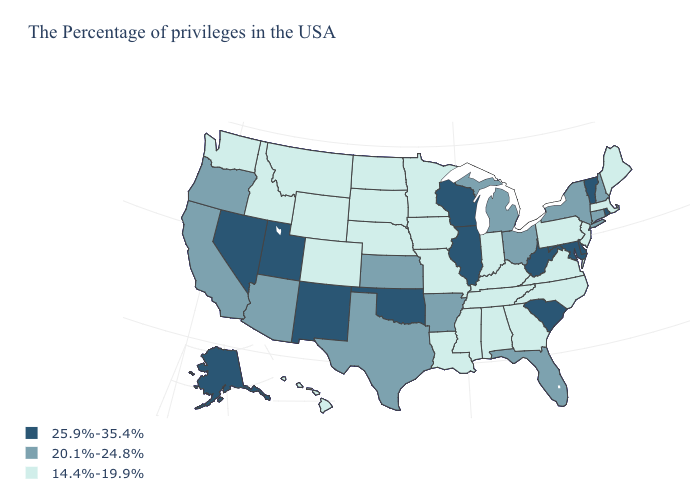Among the states that border Rhode Island , which have the highest value?
Answer briefly. Connecticut. Name the states that have a value in the range 14.4%-19.9%?
Concise answer only. Maine, Massachusetts, New Jersey, Pennsylvania, Virginia, North Carolina, Georgia, Kentucky, Indiana, Alabama, Tennessee, Mississippi, Louisiana, Missouri, Minnesota, Iowa, Nebraska, South Dakota, North Dakota, Wyoming, Colorado, Montana, Idaho, Washington, Hawaii. Does New Mexico have the highest value in the West?
Quick response, please. Yes. What is the highest value in the MidWest ?
Be succinct. 25.9%-35.4%. Name the states that have a value in the range 20.1%-24.8%?
Keep it brief. New Hampshire, Connecticut, New York, Ohio, Florida, Michigan, Arkansas, Kansas, Texas, Arizona, California, Oregon. Name the states that have a value in the range 25.9%-35.4%?
Give a very brief answer. Rhode Island, Vermont, Delaware, Maryland, South Carolina, West Virginia, Wisconsin, Illinois, Oklahoma, New Mexico, Utah, Nevada, Alaska. What is the highest value in the USA?
Quick response, please. 25.9%-35.4%. Name the states that have a value in the range 25.9%-35.4%?
Short answer required. Rhode Island, Vermont, Delaware, Maryland, South Carolina, West Virginia, Wisconsin, Illinois, Oklahoma, New Mexico, Utah, Nevada, Alaska. Which states have the lowest value in the USA?
Give a very brief answer. Maine, Massachusetts, New Jersey, Pennsylvania, Virginia, North Carolina, Georgia, Kentucky, Indiana, Alabama, Tennessee, Mississippi, Louisiana, Missouri, Minnesota, Iowa, Nebraska, South Dakota, North Dakota, Wyoming, Colorado, Montana, Idaho, Washington, Hawaii. What is the highest value in states that border Kansas?
Answer briefly. 25.9%-35.4%. Name the states that have a value in the range 14.4%-19.9%?
Be succinct. Maine, Massachusetts, New Jersey, Pennsylvania, Virginia, North Carolina, Georgia, Kentucky, Indiana, Alabama, Tennessee, Mississippi, Louisiana, Missouri, Minnesota, Iowa, Nebraska, South Dakota, North Dakota, Wyoming, Colorado, Montana, Idaho, Washington, Hawaii. Does the map have missing data?
Answer briefly. No. Which states have the lowest value in the South?
Be succinct. Virginia, North Carolina, Georgia, Kentucky, Alabama, Tennessee, Mississippi, Louisiana. Name the states that have a value in the range 14.4%-19.9%?
Quick response, please. Maine, Massachusetts, New Jersey, Pennsylvania, Virginia, North Carolina, Georgia, Kentucky, Indiana, Alabama, Tennessee, Mississippi, Louisiana, Missouri, Minnesota, Iowa, Nebraska, South Dakota, North Dakota, Wyoming, Colorado, Montana, Idaho, Washington, Hawaii. Does Illinois have the highest value in the USA?
Keep it brief. Yes. 